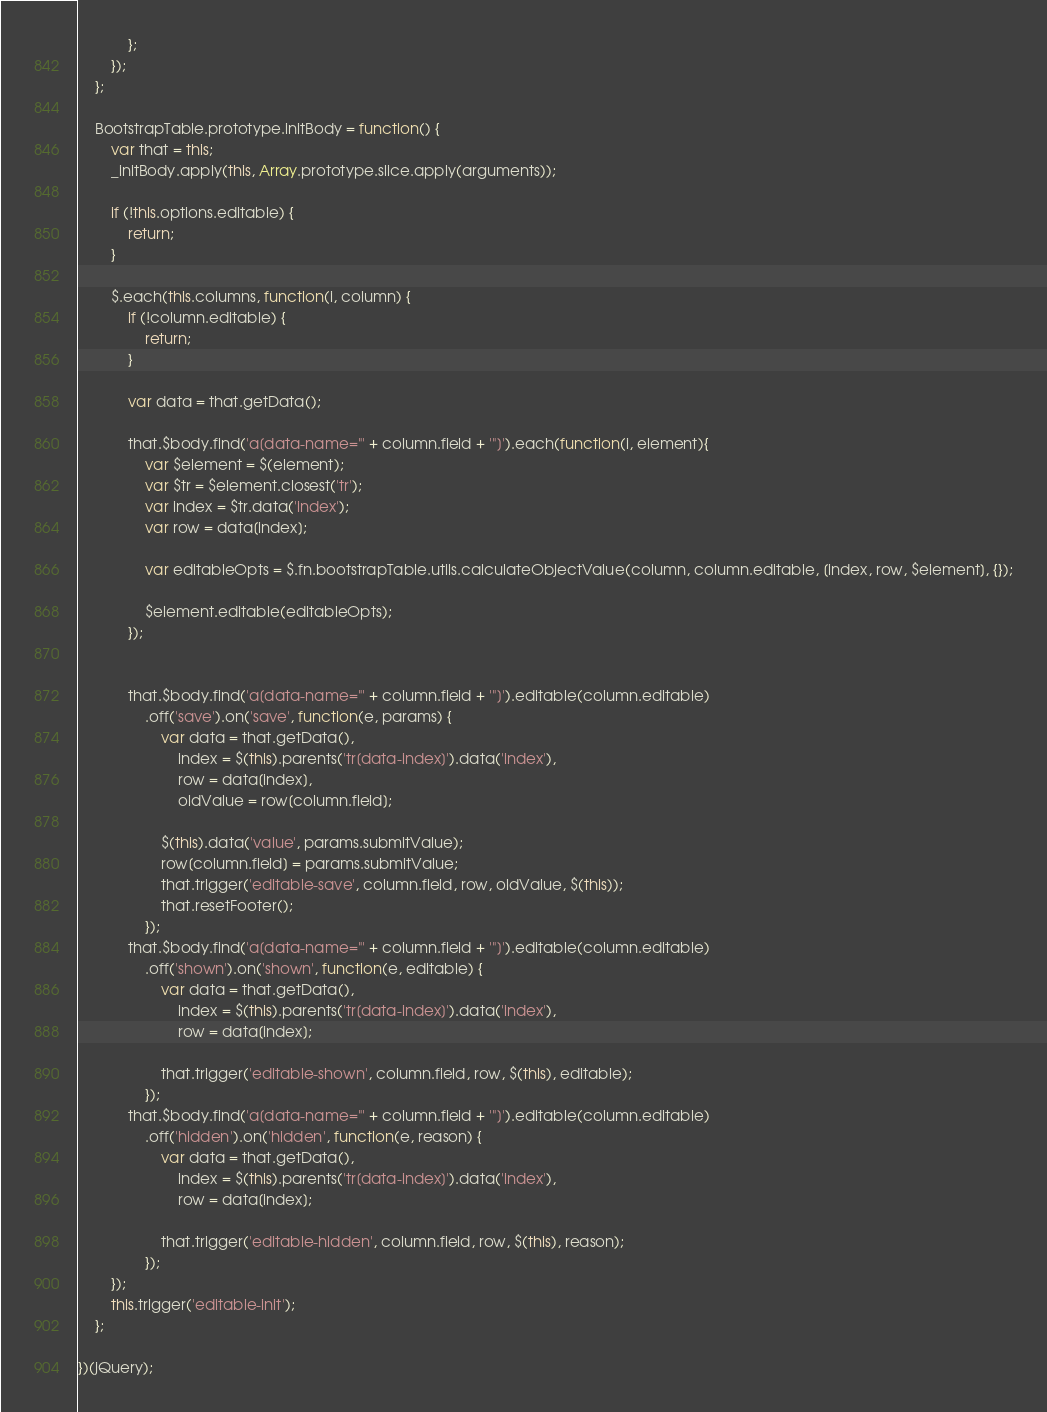<code> <loc_0><loc_0><loc_500><loc_500><_JavaScript_>
            };
        });
    };

    BootstrapTable.prototype.initBody = function() {
        var that = this;
        _initBody.apply(this, Array.prototype.slice.apply(arguments));

        if (!this.options.editable) {
            return;
        }

        $.each(this.columns, function(i, column) {
            if (!column.editable) {
                return;
            }

            var data = that.getData();

            that.$body.find('a[data-name="' + column.field + '"]').each(function(i, element){
                var $element = $(element);
                var $tr = $element.closest('tr');
                var index = $tr.data('index');
                var row = data[index];

                var editableOpts = $.fn.bootstrapTable.utils.calculateObjectValue(column, column.editable, [index, row, $element], {});

                $element.editable(editableOpts);
            });


            that.$body.find('a[data-name="' + column.field + '"]').editable(column.editable)
                .off('save').on('save', function(e, params) {
                    var data = that.getData(),
                        index = $(this).parents('tr[data-index]').data('index'),
                        row = data[index],
                        oldValue = row[column.field];

                    $(this).data('value', params.submitValue);
                    row[column.field] = params.submitValue;
                    that.trigger('editable-save', column.field, row, oldValue, $(this));
                    that.resetFooter();
                });
            that.$body.find('a[data-name="' + column.field + '"]').editable(column.editable)
                .off('shown').on('shown', function(e, editable) {
                    var data = that.getData(),
                        index = $(this).parents('tr[data-index]').data('index'),
                        row = data[index];

                    that.trigger('editable-shown', column.field, row, $(this), editable);
                });
            that.$body.find('a[data-name="' + column.field + '"]').editable(column.editable)
                .off('hidden').on('hidden', function(e, reason) {
                    var data = that.getData(),
                        index = $(this).parents('tr[data-index]').data('index'),
                        row = data[index];

                    that.trigger('editable-hidden', column.field, row, $(this), reason);
                });
        });
        this.trigger('editable-init');
    };

})(jQuery);
</code> 